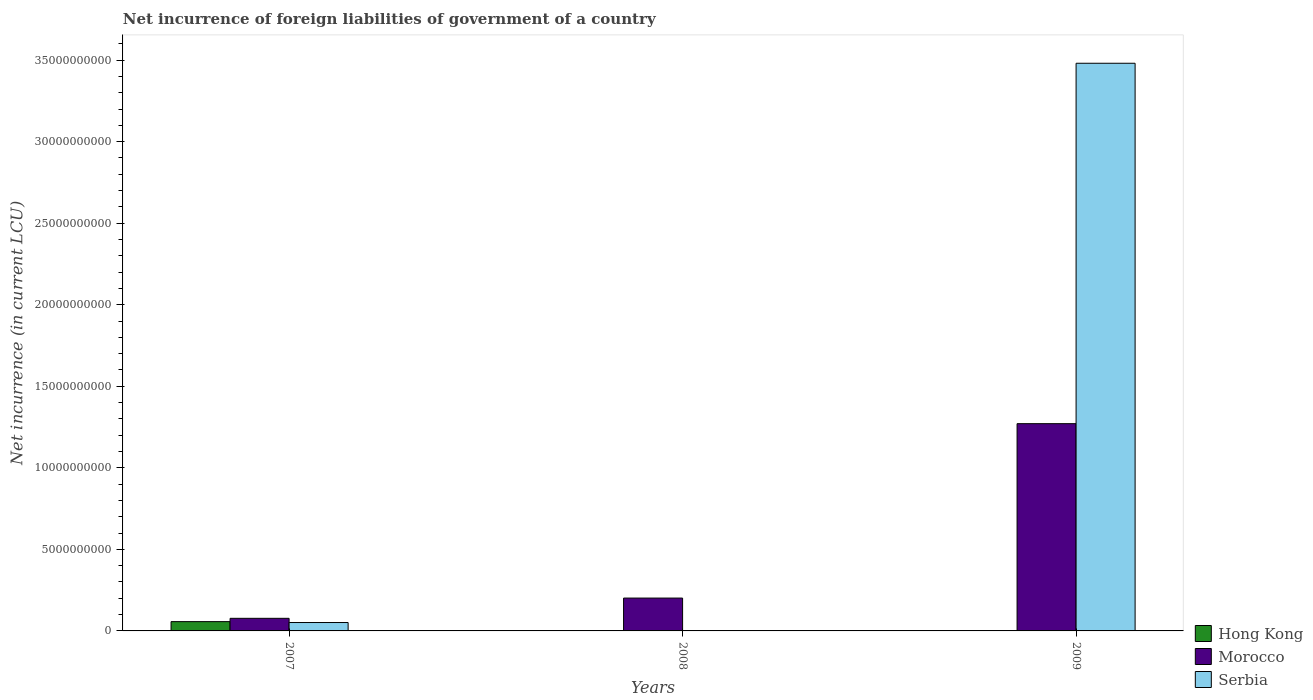How many different coloured bars are there?
Your answer should be very brief. 3. Are the number of bars on each tick of the X-axis equal?
Make the answer very short. No. How many bars are there on the 3rd tick from the left?
Offer a terse response. 2. What is the label of the 3rd group of bars from the left?
Offer a terse response. 2009. In how many cases, is the number of bars for a given year not equal to the number of legend labels?
Give a very brief answer. 2. What is the net incurrence of foreign liabilities in Hong Kong in 2007?
Provide a short and direct response. 5.70e+08. Across all years, what is the maximum net incurrence of foreign liabilities in Hong Kong?
Provide a short and direct response. 5.70e+08. Across all years, what is the minimum net incurrence of foreign liabilities in Morocco?
Your answer should be compact. 7.73e+08. In which year was the net incurrence of foreign liabilities in Hong Kong maximum?
Keep it short and to the point. 2007. What is the total net incurrence of foreign liabilities in Morocco in the graph?
Your answer should be very brief. 1.55e+1. What is the difference between the net incurrence of foreign liabilities in Serbia in 2007 and that in 2009?
Your response must be concise. -3.43e+1. What is the difference between the net incurrence of foreign liabilities in Morocco in 2008 and the net incurrence of foreign liabilities in Hong Kong in 2009?
Give a very brief answer. 2.01e+09. What is the average net incurrence of foreign liabilities in Hong Kong per year?
Offer a terse response. 1.90e+08. In the year 2007, what is the difference between the net incurrence of foreign liabilities in Serbia and net incurrence of foreign liabilities in Hong Kong?
Provide a short and direct response. -5.47e+07. What is the ratio of the net incurrence of foreign liabilities in Serbia in 2007 to that in 2009?
Give a very brief answer. 0.01. What is the difference between the highest and the second highest net incurrence of foreign liabilities in Morocco?
Keep it short and to the point. 1.07e+1. What is the difference between the highest and the lowest net incurrence of foreign liabilities in Hong Kong?
Provide a succinct answer. 5.70e+08. How many bars are there?
Offer a terse response. 6. Are all the bars in the graph horizontal?
Ensure brevity in your answer.  No. How many years are there in the graph?
Ensure brevity in your answer.  3. What is the difference between two consecutive major ticks on the Y-axis?
Keep it short and to the point. 5.00e+09. Are the values on the major ticks of Y-axis written in scientific E-notation?
Provide a short and direct response. No. Does the graph contain grids?
Ensure brevity in your answer.  No. Where does the legend appear in the graph?
Offer a terse response. Bottom right. What is the title of the graph?
Keep it short and to the point. Net incurrence of foreign liabilities of government of a country. Does "Hong Kong" appear as one of the legend labels in the graph?
Your response must be concise. Yes. What is the label or title of the Y-axis?
Your response must be concise. Net incurrence (in current LCU). What is the Net incurrence (in current LCU) in Hong Kong in 2007?
Offer a terse response. 5.70e+08. What is the Net incurrence (in current LCU) in Morocco in 2007?
Your answer should be compact. 7.73e+08. What is the Net incurrence (in current LCU) of Serbia in 2007?
Make the answer very short. 5.15e+08. What is the Net incurrence (in current LCU) of Hong Kong in 2008?
Make the answer very short. 0. What is the Net incurrence (in current LCU) in Morocco in 2008?
Your answer should be compact. 2.01e+09. What is the Net incurrence (in current LCU) of Hong Kong in 2009?
Offer a very short reply. 0. What is the Net incurrence (in current LCU) of Morocco in 2009?
Offer a terse response. 1.27e+1. What is the Net incurrence (in current LCU) of Serbia in 2009?
Provide a short and direct response. 3.48e+1. Across all years, what is the maximum Net incurrence (in current LCU) in Hong Kong?
Your response must be concise. 5.70e+08. Across all years, what is the maximum Net incurrence (in current LCU) of Morocco?
Give a very brief answer. 1.27e+1. Across all years, what is the maximum Net incurrence (in current LCU) of Serbia?
Your answer should be compact. 3.48e+1. Across all years, what is the minimum Net incurrence (in current LCU) of Hong Kong?
Provide a short and direct response. 0. Across all years, what is the minimum Net incurrence (in current LCU) in Morocco?
Your answer should be very brief. 7.73e+08. What is the total Net incurrence (in current LCU) of Hong Kong in the graph?
Provide a short and direct response. 5.70e+08. What is the total Net incurrence (in current LCU) in Morocco in the graph?
Offer a terse response. 1.55e+1. What is the total Net incurrence (in current LCU) in Serbia in the graph?
Your answer should be compact. 3.53e+1. What is the difference between the Net incurrence (in current LCU) in Morocco in 2007 and that in 2008?
Give a very brief answer. -1.24e+09. What is the difference between the Net incurrence (in current LCU) in Morocco in 2007 and that in 2009?
Offer a terse response. -1.19e+1. What is the difference between the Net incurrence (in current LCU) in Serbia in 2007 and that in 2009?
Make the answer very short. -3.43e+1. What is the difference between the Net incurrence (in current LCU) in Morocco in 2008 and that in 2009?
Your answer should be very brief. -1.07e+1. What is the difference between the Net incurrence (in current LCU) in Hong Kong in 2007 and the Net incurrence (in current LCU) in Morocco in 2008?
Give a very brief answer. -1.44e+09. What is the difference between the Net incurrence (in current LCU) of Hong Kong in 2007 and the Net incurrence (in current LCU) of Morocco in 2009?
Ensure brevity in your answer.  -1.21e+1. What is the difference between the Net incurrence (in current LCU) of Hong Kong in 2007 and the Net incurrence (in current LCU) of Serbia in 2009?
Make the answer very short. -3.42e+1. What is the difference between the Net incurrence (in current LCU) in Morocco in 2007 and the Net incurrence (in current LCU) in Serbia in 2009?
Ensure brevity in your answer.  -3.40e+1. What is the difference between the Net incurrence (in current LCU) in Morocco in 2008 and the Net incurrence (in current LCU) in Serbia in 2009?
Ensure brevity in your answer.  -3.28e+1. What is the average Net incurrence (in current LCU) of Hong Kong per year?
Give a very brief answer. 1.90e+08. What is the average Net incurrence (in current LCU) of Morocco per year?
Offer a terse response. 5.16e+09. What is the average Net incurrence (in current LCU) of Serbia per year?
Your answer should be very brief. 1.18e+1. In the year 2007, what is the difference between the Net incurrence (in current LCU) of Hong Kong and Net incurrence (in current LCU) of Morocco?
Your response must be concise. -2.03e+08. In the year 2007, what is the difference between the Net incurrence (in current LCU) in Hong Kong and Net incurrence (in current LCU) in Serbia?
Your response must be concise. 5.47e+07. In the year 2007, what is the difference between the Net incurrence (in current LCU) of Morocco and Net incurrence (in current LCU) of Serbia?
Give a very brief answer. 2.58e+08. In the year 2009, what is the difference between the Net incurrence (in current LCU) in Morocco and Net incurrence (in current LCU) in Serbia?
Provide a short and direct response. -2.21e+1. What is the ratio of the Net incurrence (in current LCU) of Morocco in 2007 to that in 2008?
Keep it short and to the point. 0.38. What is the ratio of the Net incurrence (in current LCU) in Morocco in 2007 to that in 2009?
Offer a terse response. 0.06. What is the ratio of the Net incurrence (in current LCU) in Serbia in 2007 to that in 2009?
Give a very brief answer. 0.01. What is the ratio of the Net incurrence (in current LCU) of Morocco in 2008 to that in 2009?
Your response must be concise. 0.16. What is the difference between the highest and the second highest Net incurrence (in current LCU) of Morocco?
Ensure brevity in your answer.  1.07e+1. What is the difference between the highest and the lowest Net incurrence (in current LCU) of Hong Kong?
Keep it short and to the point. 5.70e+08. What is the difference between the highest and the lowest Net incurrence (in current LCU) in Morocco?
Provide a succinct answer. 1.19e+1. What is the difference between the highest and the lowest Net incurrence (in current LCU) of Serbia?
Your answer should be compact. 3.48e+1. 